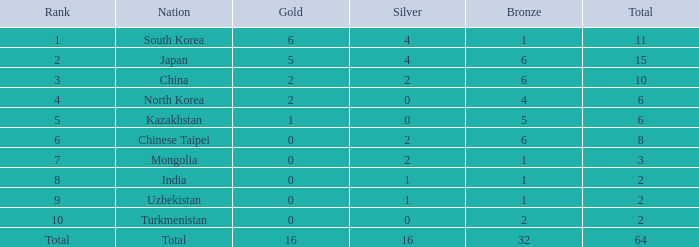In terms of ranking, where does turkmenistan stand with 0 silvers and fewer than 2 golds? 10.0. 